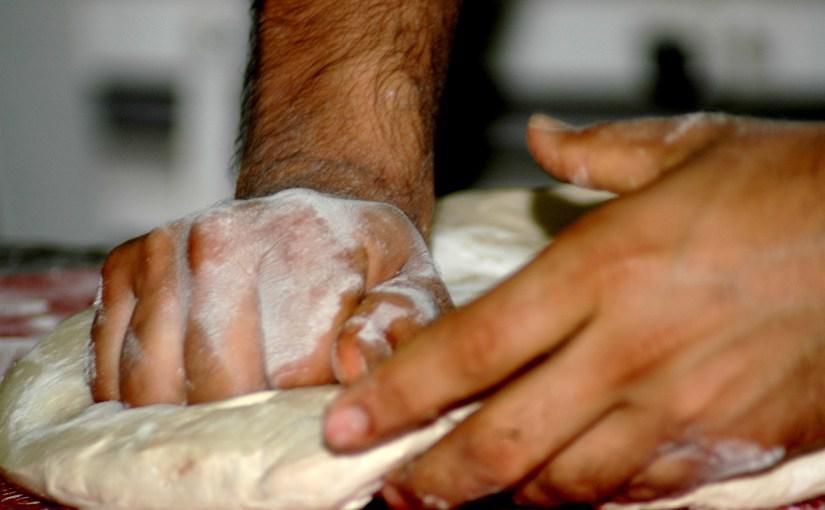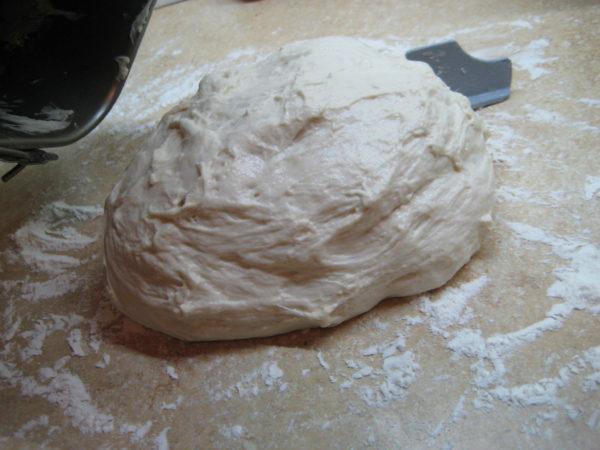The first image is the image on the left, the second image is the image on the right. For the images displayed, is the sentence "One and only one of the two images has hands in it." factually correct? Answer yes or no. Yes. The first image is the image on the left, the second image is the image on the right. Analyze the images presented: Is the assertion "A person is shaping dough by hand." valid? Answer yes or no. Yes. 